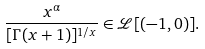Convert formula to latex. <formula><loc_0><loc_0><loc_500><loc_500>\frac { x ^ { \alpha } } { [ \Gamma ( x + 1 ) ] ^ { 1 / x } } \in \mathcal { L } [ ( - 1 , 0 ) ] .</formula> 